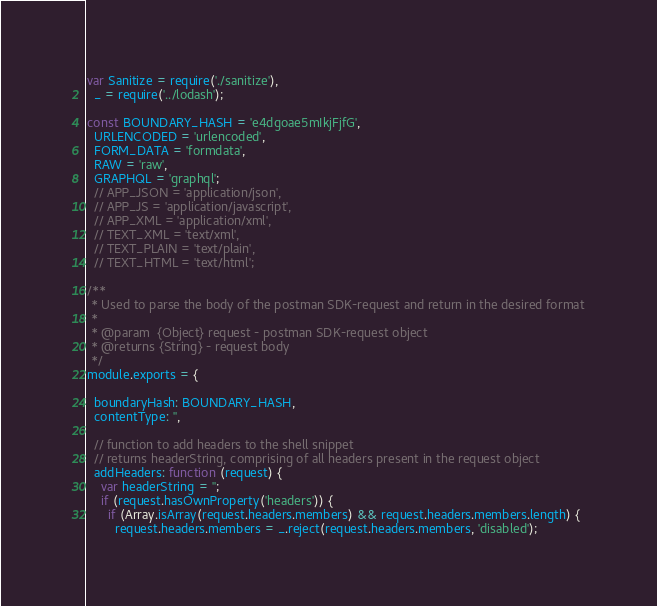<code> <loc_0><loc_0><loc_500><loc_500><_JavaScript_>var Sanitize = require('./sanitize'),
  _ = require('../lodash');

const BOUNDARY_HASH = 'e4dgoae5mIkjFjfG',
  URLENCODED = 'urlencoded',
  FORM_DATA = 'formdata',
  RAW = 'raw',
  GRAPHQL = 'graphql';
  // APP_JSON = 'application/json',
  // APP_JS = 'application/javascript',
  // APP_XML = 'application/xml',
  // TEXT_XML = 'text/xml',
  // TEXT_PLAIN = 'text/plain',
  // TEXT_HTML = 'text/html';

/**
 * Used to parse the body of the postman SDK-request and return in the desired format
 *
 * @param  {Object} request - postman SDK-request object
 * @returns {String} - request body
 */
module.exports = {

  boundaryHash: BOUNDARY_HASH,
  contentType: '',

  // function to add headers to the shell snippet
  // returns headerString, comprising of all headers present in the request object
  addHeaders: function (request) {
    var headerString = '';
    if (request.hasOwnProperty('headers')) {
      if (Array.isArray(request.headers.members) && request.headers.members.length) {
        request.headers.members = _.reject(request.headers.members, 'disabled');</code> 